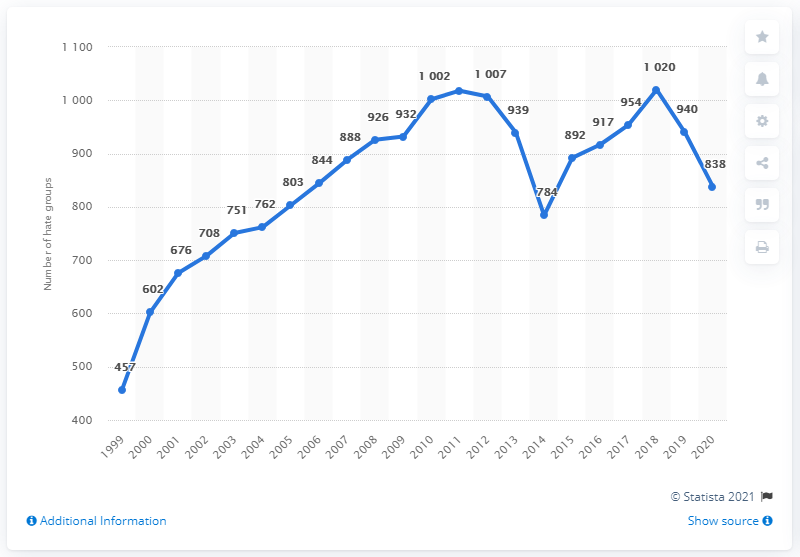Point out several critical features in this image. The average of 2018, 2019, and 2020 is 932.7. There were 838 active hate groups in the United States in 2020. In 2005, the value is closer to 800. 